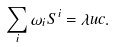Convert formula to latex. <formula><loc_0><loc_0><loc_500><loc_500>\sum _ { i } \omega _ { i } S ^ { i } = \lambda u c .</formula> 